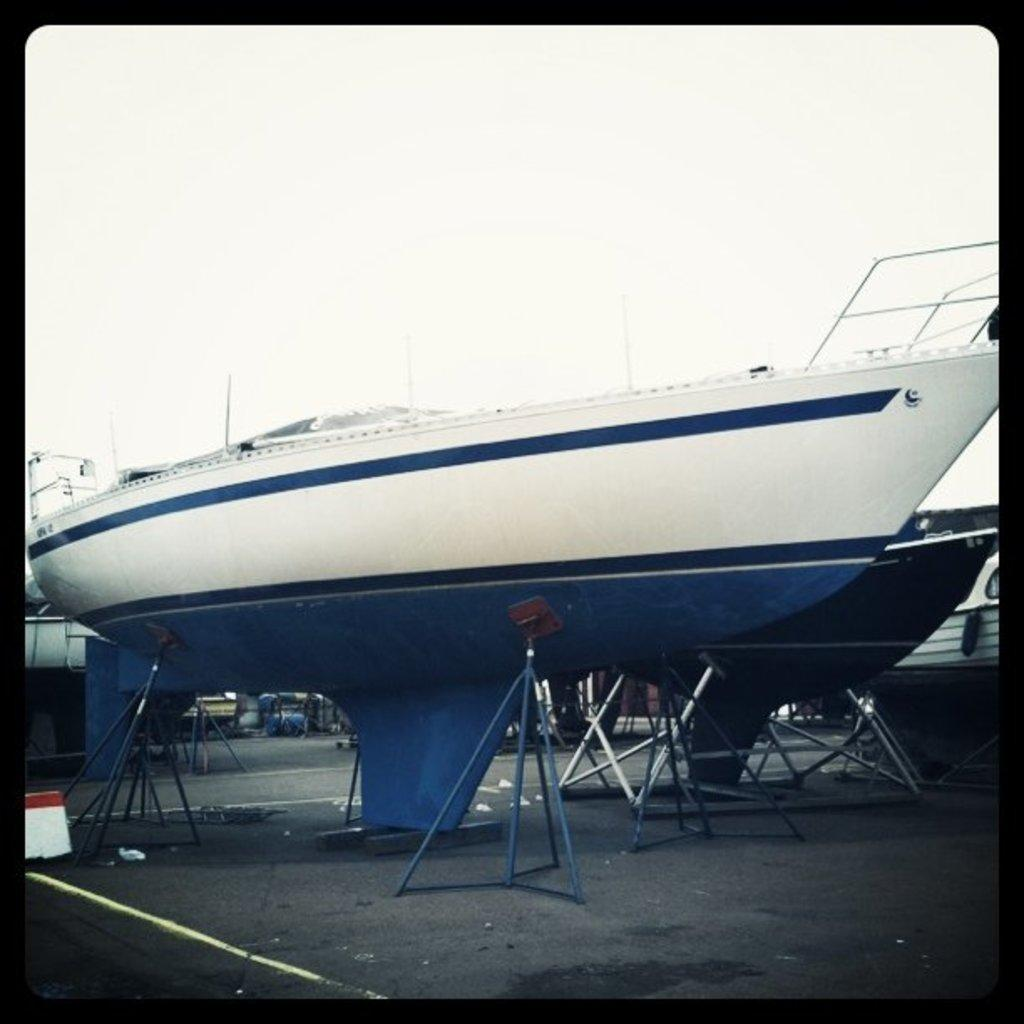What is the main subject of the image? The main subject of the image is a group of boats. How are the boats positioned in the image? The boats are placed on the ground with the help of rods. What can be seen in the background of the image? There is a sky visible in the background of the image. How many brothers are depicted in the image? There are no brothers present in the image; it features a group of boats. What type of jam is being spread on the boats in the image? There is no jam present in the image; it features a group of boats placed on the ground with the help of rods. 